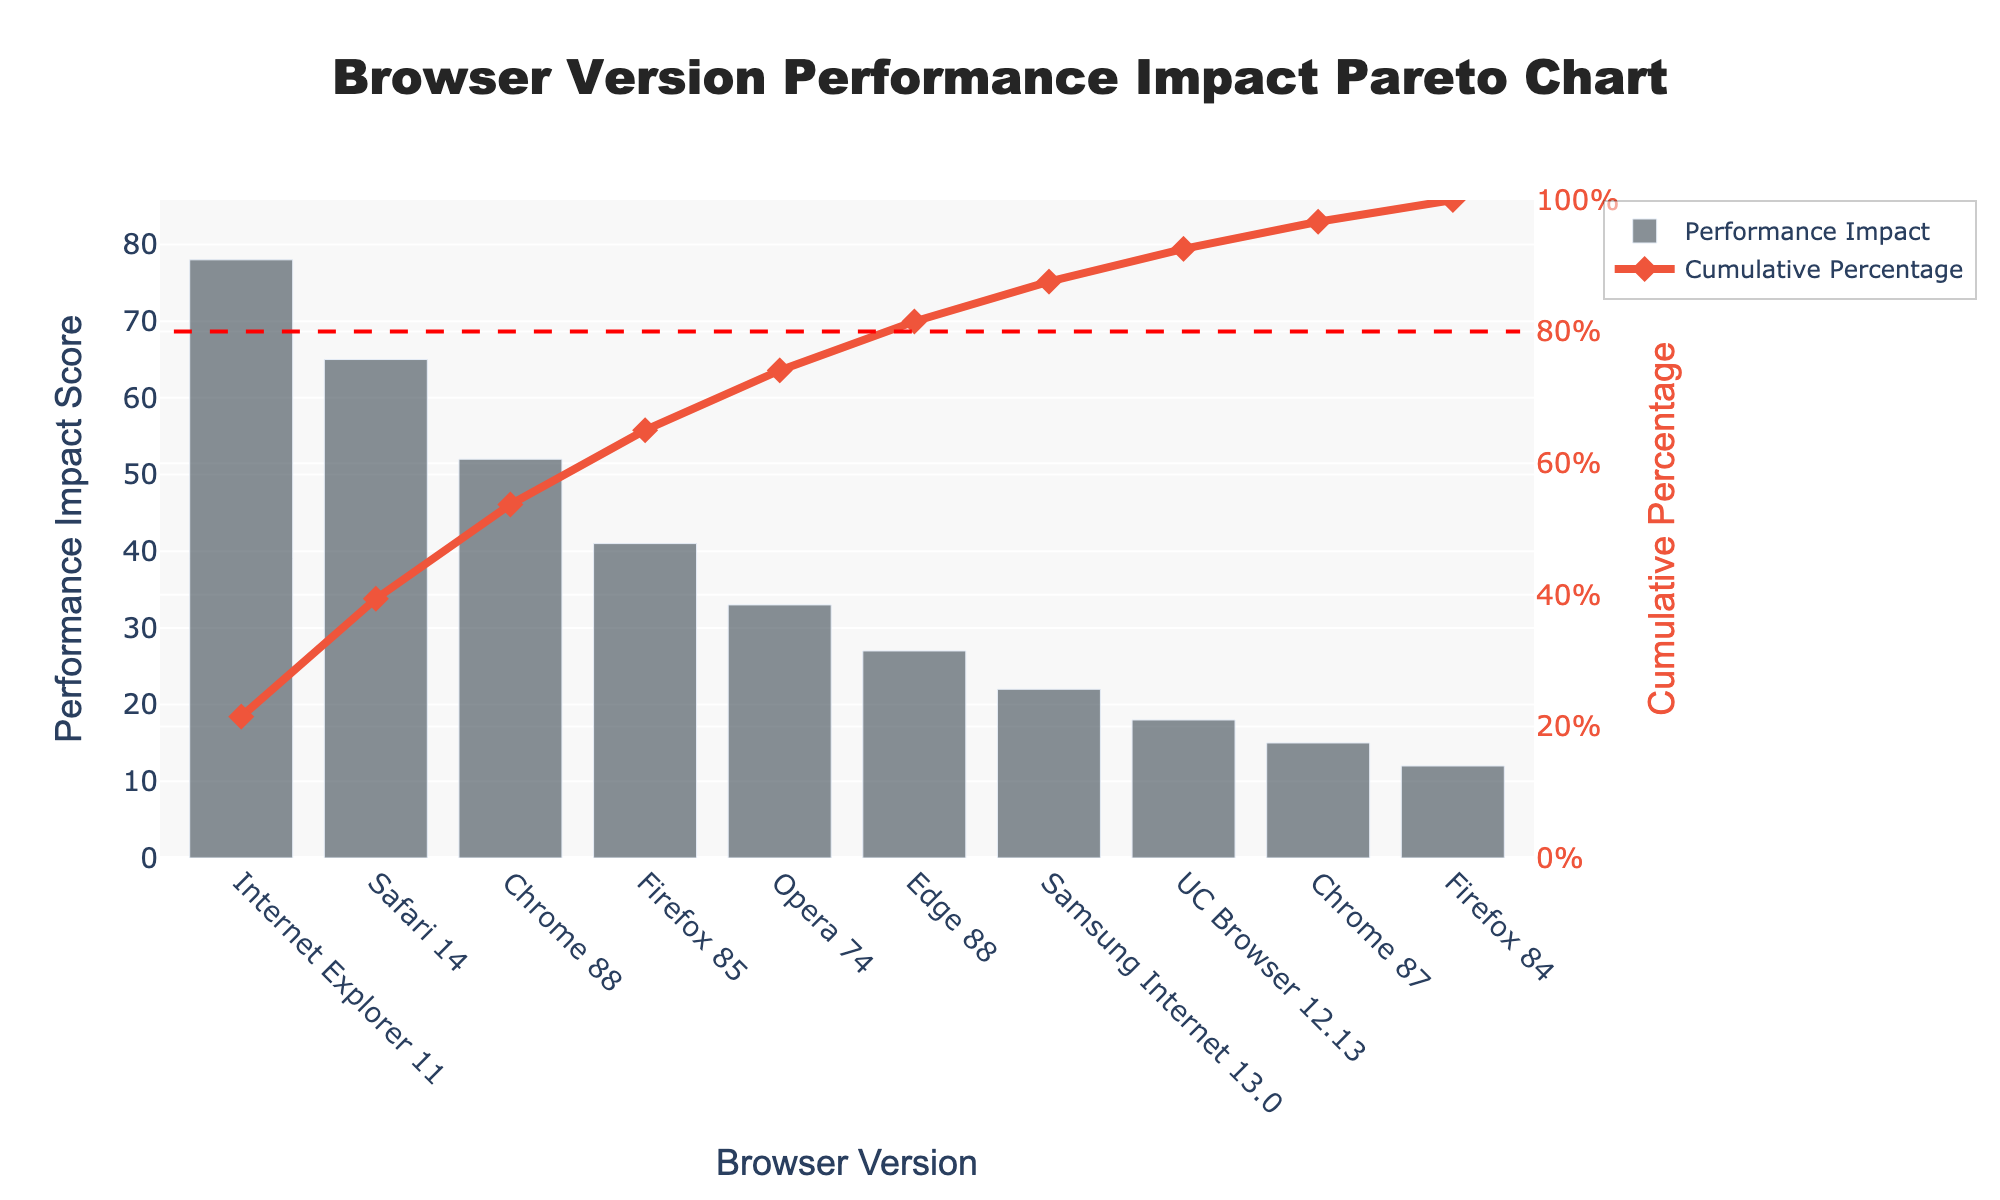Which browser version has the highest performance impact score? To find out which browser version has the highest performance impact score, we look at the bars on the chart and identify which one is the tallest. The tallest bar corresponds to Internet Explorer 11, which means it has the highest performance impact score.
Answer: Internet Explorer 11 What is the cumulative percentage for Firefox 85? To determine the cumulative percentage for Firefox 85, look at the cumulative percentage line corresponding to the Firefox 85 bar. According to the chart, the cumulative percentage for Firefox 85 is around 85%.
Answer: Around 85% How many browser versions contribute to achieving at least 80% of the cumulative performance impact? To figure out how many browser versions contribute to at least 80% of the cumulative performance impact, observe where the cumulative percentage line intersects the 80% mark (which is indicated by the red dashed line). Count the number of browser versions up to this point: Internet Explorer 11, Safari 14, Chrome 88, and Firefox 85. Therefore, four browser versions contribute to at least 80% of the cumulative performance impact.
Answer: Four browser versions What is the performance impact score for Safari 14 compared to Chrome 88? To compare the performance impact scores for Safari 14 and Chrome 88, refer to the height of the bars representing these browser versions. Safari 14 has a score of 65, while Chrome 88 has a score of 52. Therefore, Safari 14 has a higher impact score than Chrome 88.
Answer: Safari 14 has a higher impact score Which browser version has the lowest performance impact score? To identify the browser version with the lowest performance impact score, find the shortest bar in the chart. The shortest bar corresponds to Firefox 84, indicating it has the lowest performance impact score of 12.
Answer: Firefox 84 What percentage of the total performance impact is contributed by Chrome 88? To determine the percentage of the total performance impact contributed by Chrome 88, look at the cumulative percentage line for Chrome 88. Chrome 88 is the third browser from the left and has a cumulative percentage of approximately 67%. Subtract Firefox 85’s cumulative percentage (56%) from this, giving Chrome 88 an approximate relative impact of 11%.
Answer: Around 11% By what percentage does Internet Explorer 11 outperform Edge 88 in terms of performance impact score? To calculate how much Internet Explorer 11 outperforms Edge 88 in terms of impact score, subtract Edge 88's score (27) from Internet Explorer 11's score (78). Then divide this difference by Edge's score and multiply by 100 to convert it to a percentage: ((78 - 27) / 27) * 100 ≈ 188.89%.
Answer: Approximately 188.89% What is the cumulative percentage after including the performance impact of Opera 74? To determine the cumulative percentage after including Opera 74, add up the performance impact contributions chronologically until Opera 74. Opera 74 is the 5th browser from the left, and the described cumulative percentage for the fifth position from the visual interpretation is around 93%.
Answer: Around 93% 